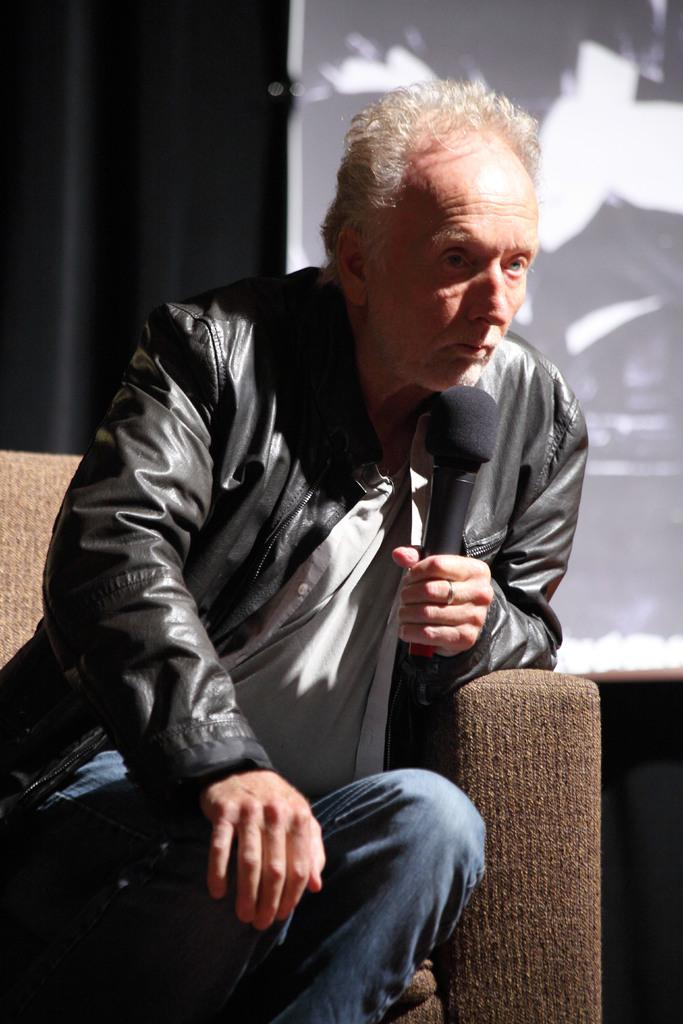What is the man in the image doing? The man is sitting on the sofa. What object is the man holding in his hand? The man is holding a microphone in his hand. What can be seen in the background of the image? There is a screen in the background of the image. What type of yam is being used as a prop in the image? There is no yam present in the image. How does the dust affect the man's ability to hold the microphone? There is no dust present in the image, so it does not affect the man's ability to hold the microphone. 